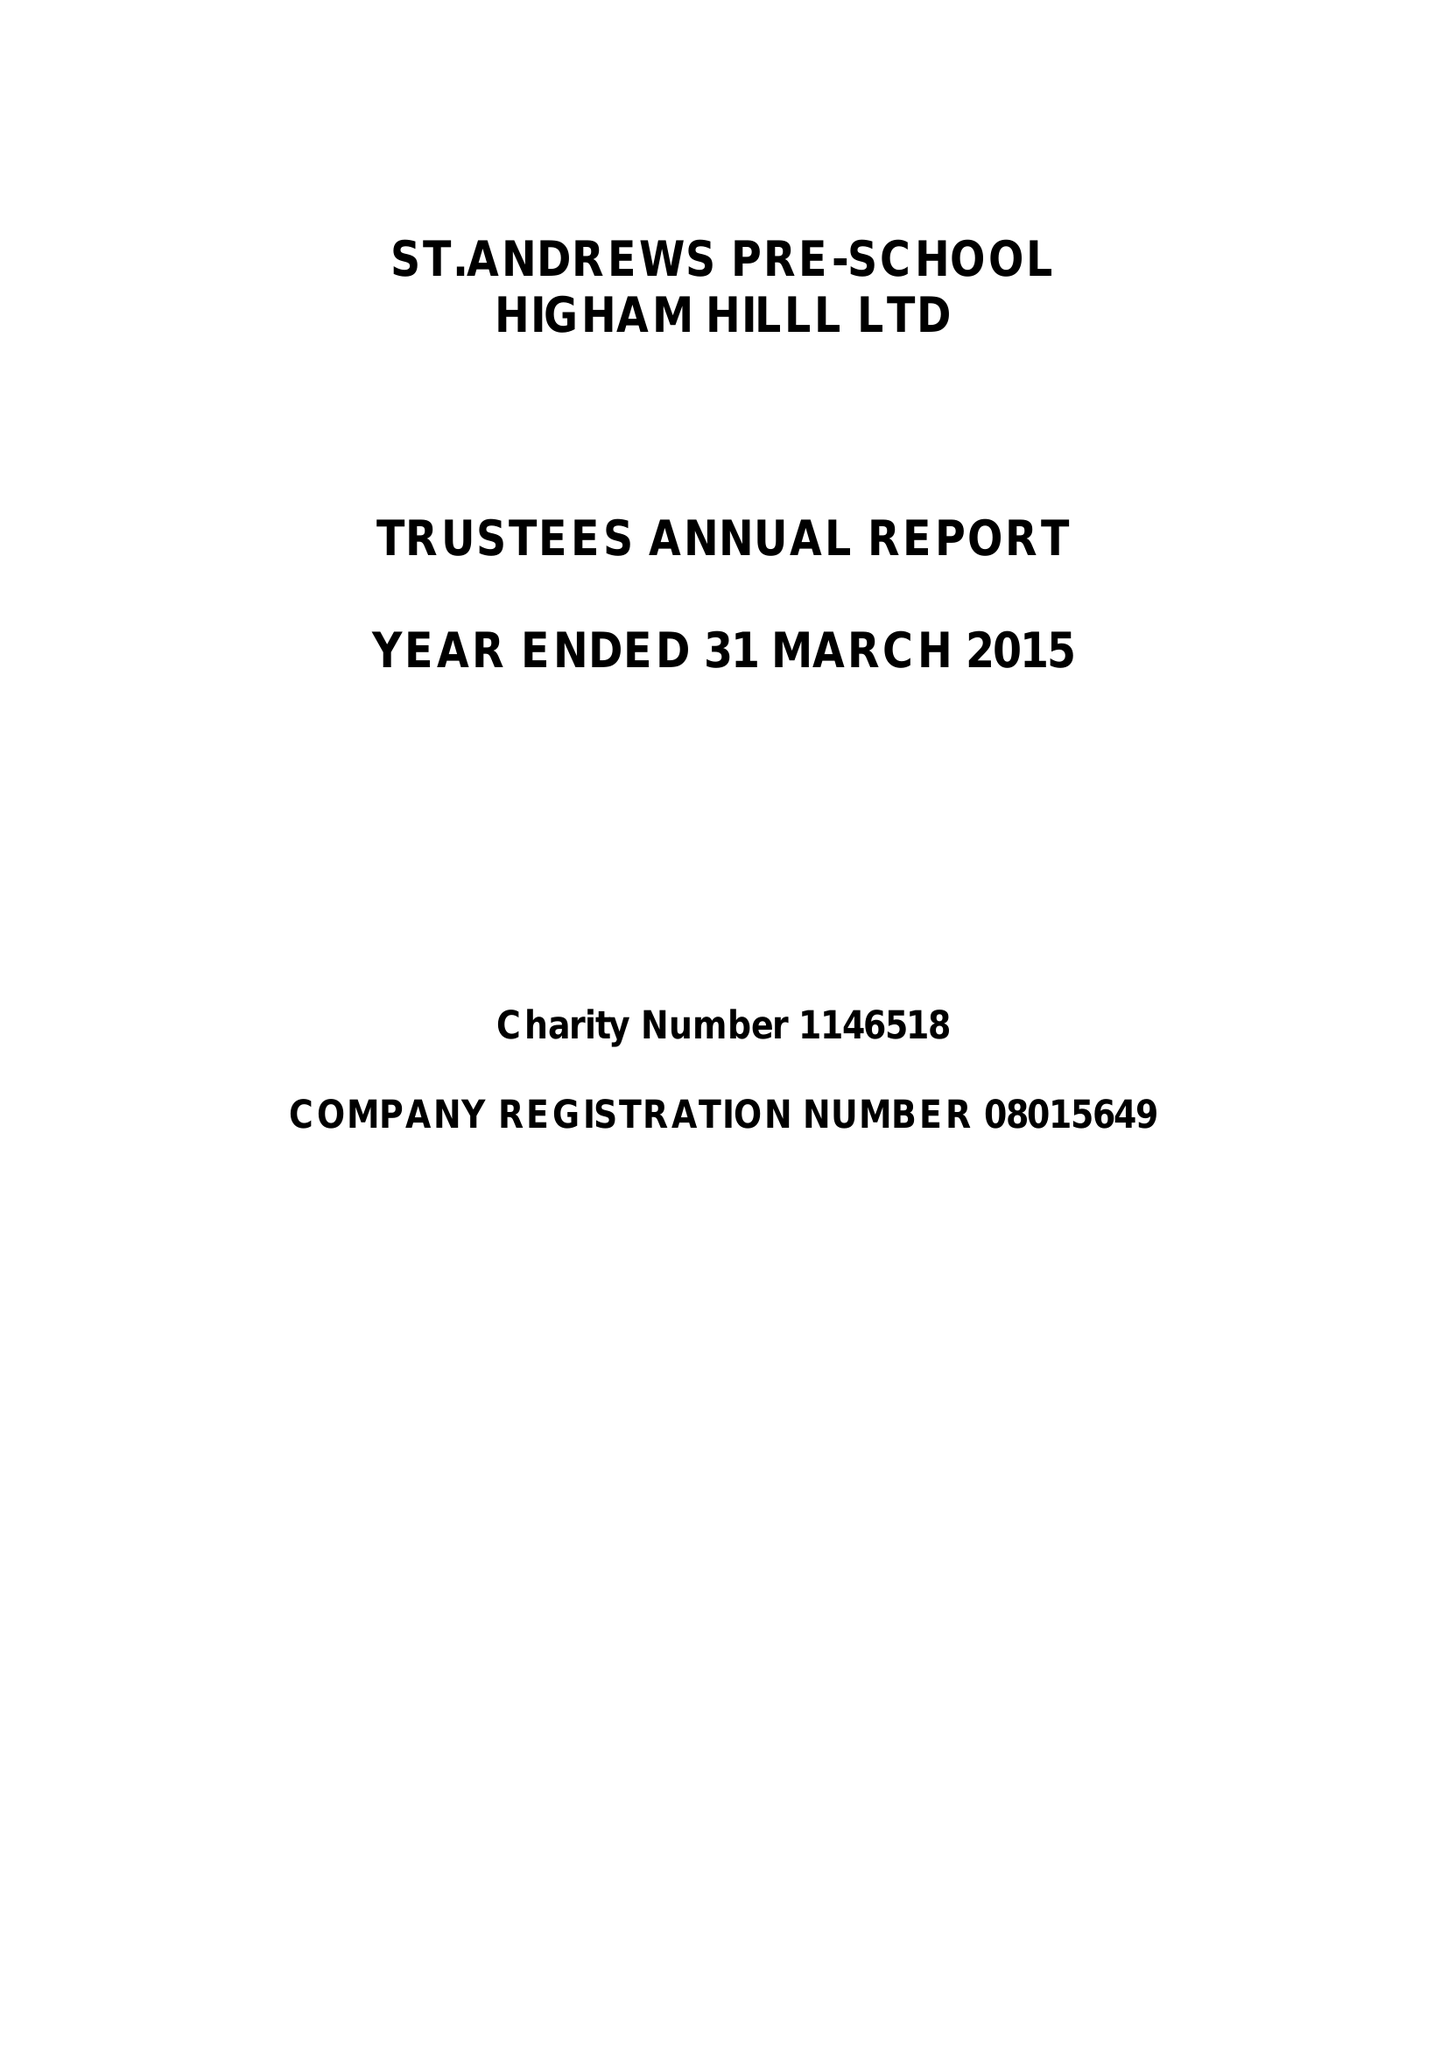What is the value for the report_date?
Answer the question using a single word or phrase. 2015-03-31 